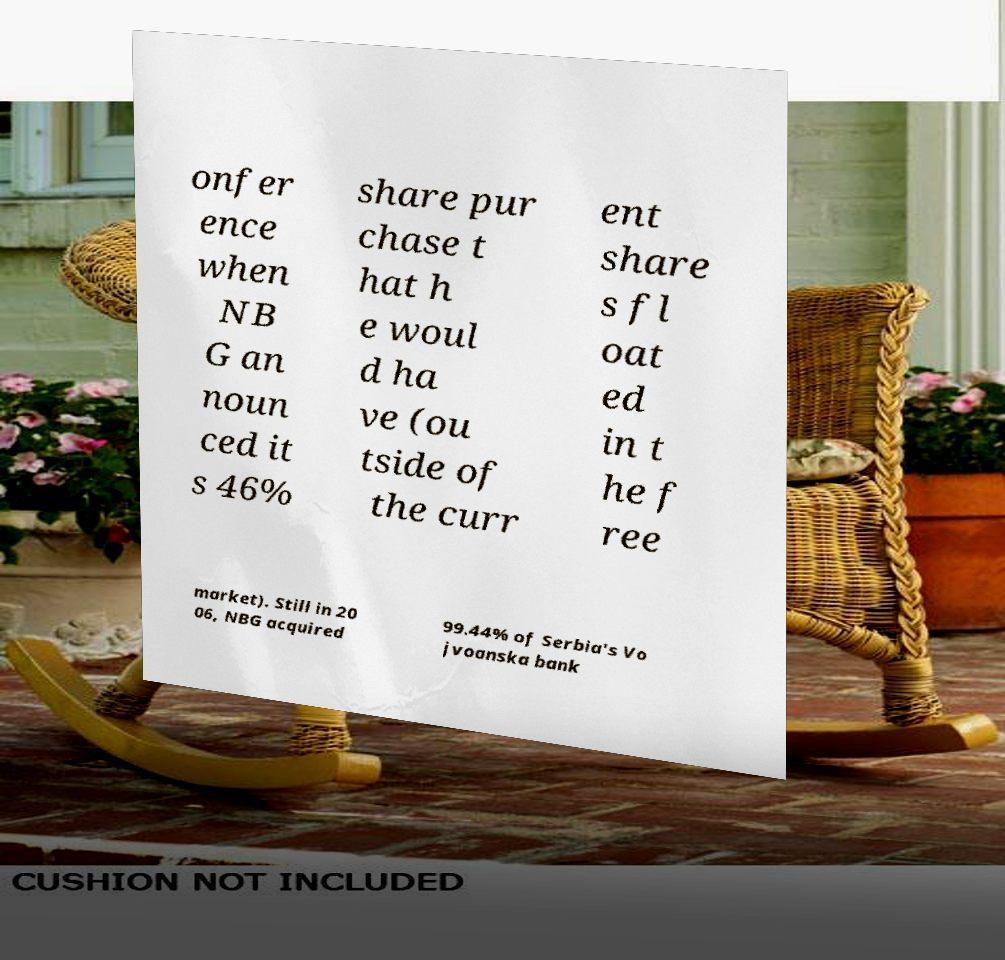There's text embedded in this image that I need extracted. Can you transcribe it verbatim? onfer ence when NB G an noun ced it s 46% share pur chase t hat h e woul d ha ve (ou tside of the curr ent share s fl oat ed in t he f ree market). Still in 20 06, NBG acquired 99.44% of Serbia's Vo jvoanska bank 